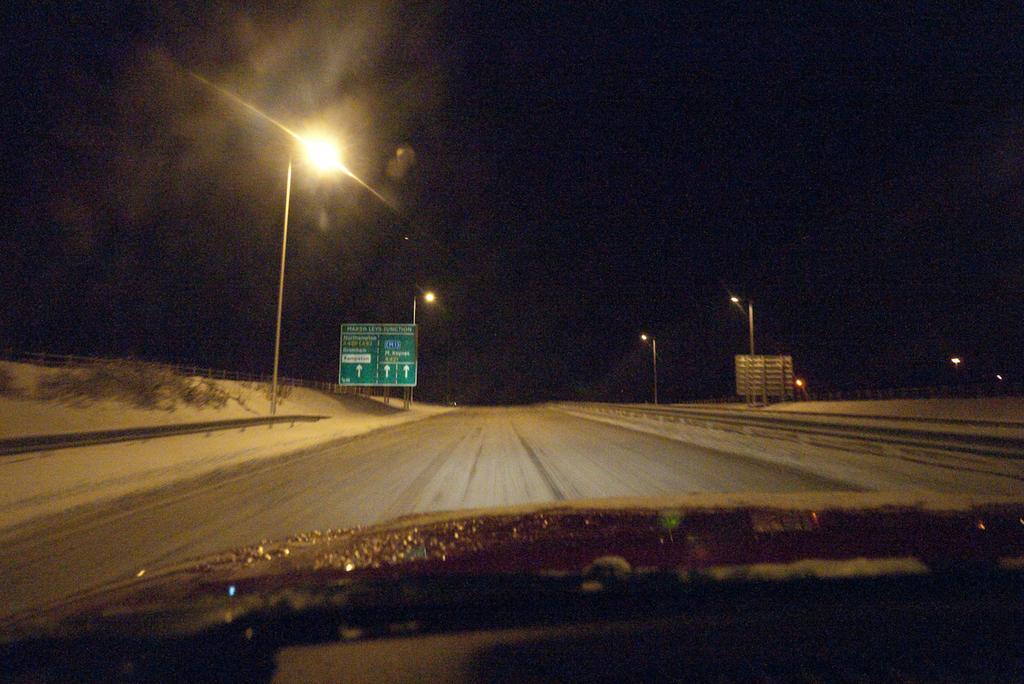In one or two sentences, can you explain what this image depicts? In the image there is a car going on the road with street lights on either side of it, this is clicked at night time. 